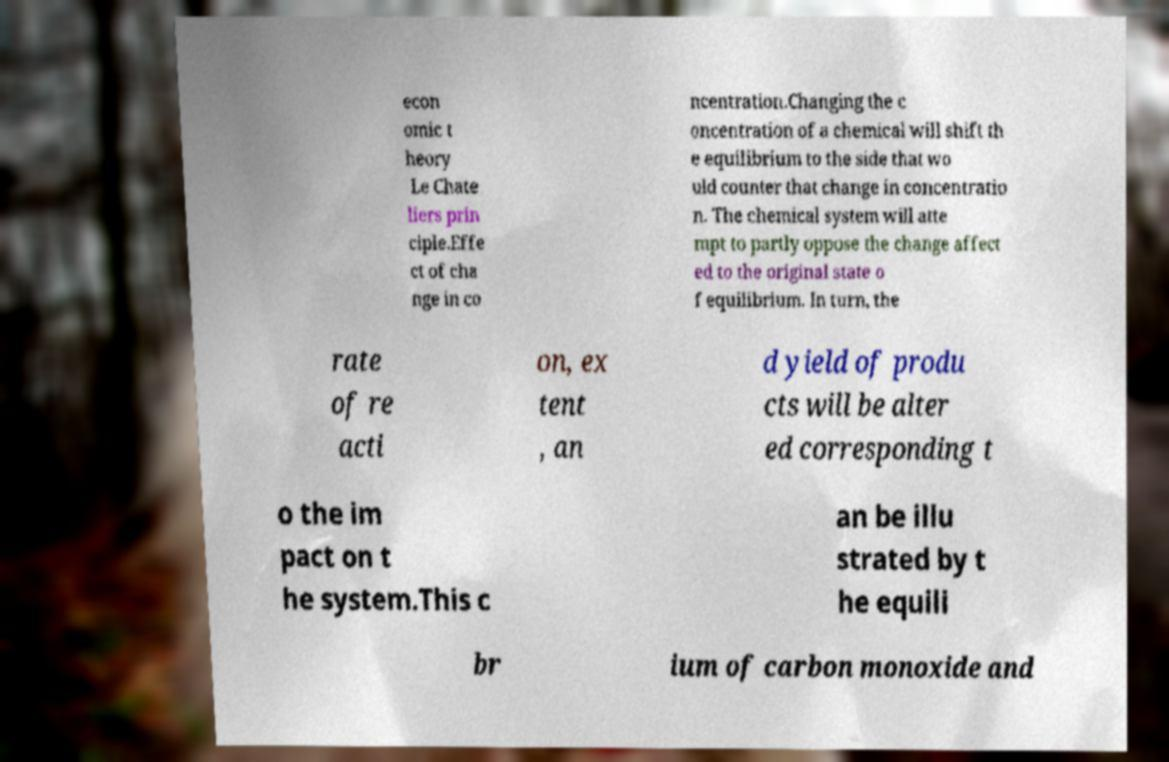Please read and relay the text visible in this image. What does it say? econ omic t heory Le Chate liers prin ciple.Effe ct of cha nge in co ncentration.Changing the c oncentration of a chemical will shift th e equilibrium to the side that wo uld counter that change in concentratio n. The chemical system will atte mpt to partly oppose the change affect ed to the original state o f equilibrium. In turn, the rate of re acti on, ex tent , an d yield of produ cts will be alter ed corresponding t o the im pact on t he system.This c an be illu strated by t he equili br ium of carbon monoxide and 